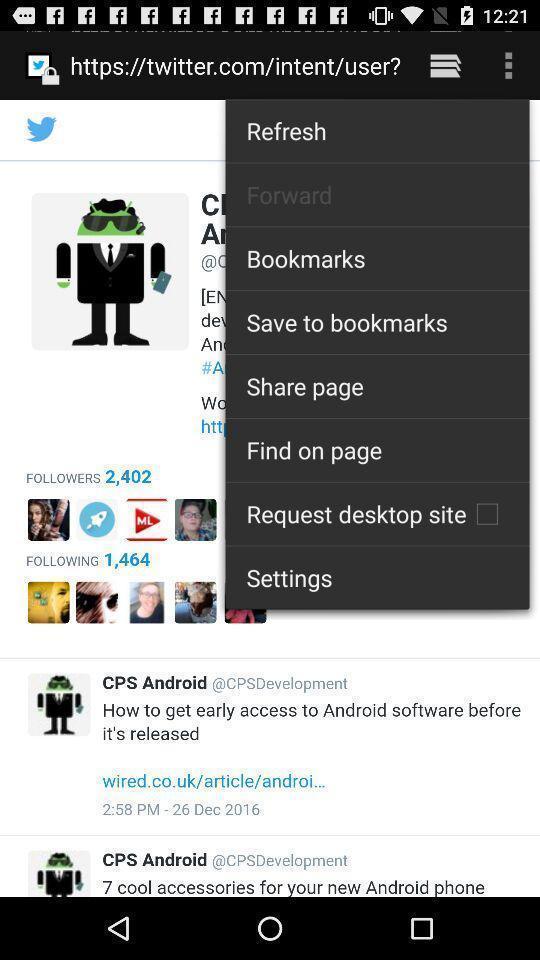Give me a summary of this screen capture. Screen shows multiple options. 